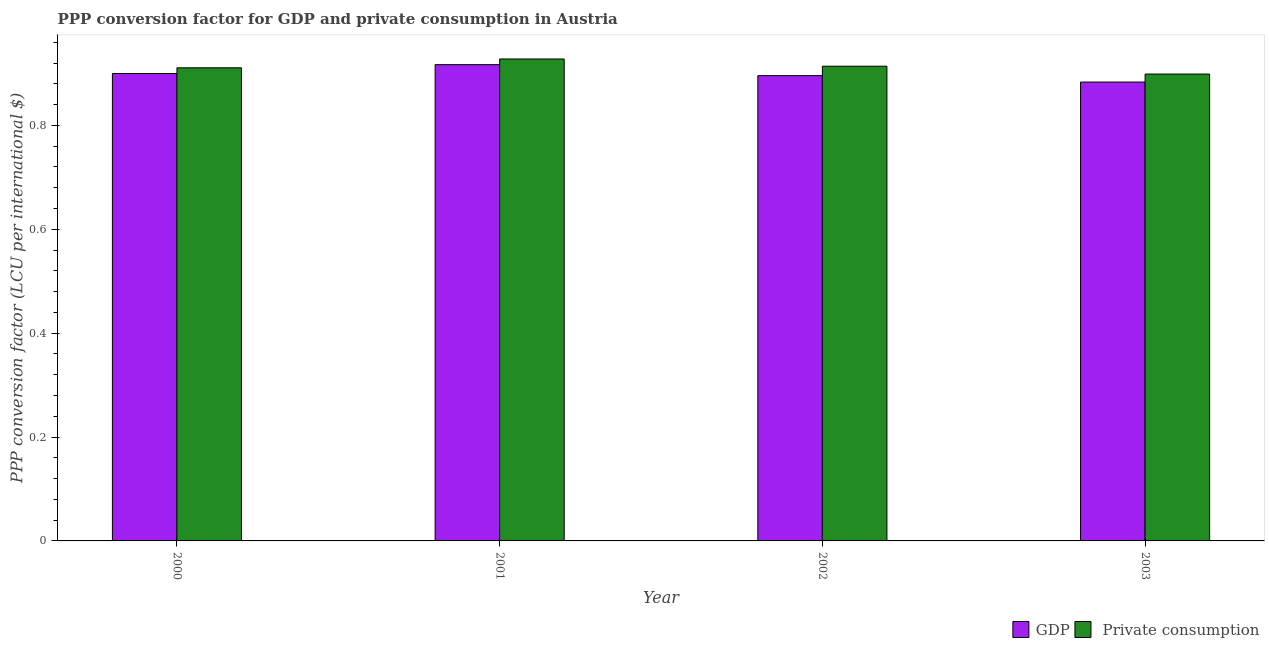Are the number of bars per tick equal to the number of legend labels?
Your answer should be very brief. Yes. How many bars are there on the 2nd tick from the left?
Your answer should be compact. 2. What is the label of the 1st group of bars from the left?
Your answer should be compact. 2000. What is the ppp conversion factor for gdp in 2003?
Keep it short and to the point. 0.88. Across all years, what is the maximum ppp conversion factor for private consumption?
Offer a very short reply. 0.93. Across all years, what is the minimum ppp conversion factor for gdp?
Your answer should be compact. 0.88. What is the total ppp conversion factor for gdp in the graph?
Your response must be concise. 3.6. What is the difference between the ppp conversion factor for gdp in 2001 and that in 2003?
Your answer should be very brief. 0.03. What is the difference between the ppp conversion factor for gdp in 2003 and the ppp conversion factor for private consumption in 2001?
Provide a succinct answer. -0.03. What is the average ppp conversion factor for private consumption per year?
Provide a succinct answer. 0.91. In the year 2001, what is the difference between the ppp conversion factor for private consumption and ppp conversion factor for gdp?
Offer a terse response. 0. What is the ratio of the ppp conversion factor for gdp in 2000 to that in 2001?
Your response must be concise. 0.98. Is the ppp conversion factor for gdp in 2001 less than that in 2003?
Offer a terse response. No. What is the difference between the highest and the second highest ppp conversion factor for private consumption?
Your response must be concise. 0.01. What is the difference between the highest and the lowest ppp conversion factor for gdp?
Make the answer very short. 0.03. In how many years, is the ppp conversion factor for gdp greater than the average ppp conversion factor for gdp taken over all years?
Keep it short and to the point. 2. What does the 2nd bar from the left in 2000 represents?
Give a very brief answer.  Private consumption. What does the 2nd bar from the right in 2002 represents?
Your answer should be compact. GDP. How many bars are there?
Make the answer very short. 8. How many years are there in the graph?
Keep it short and to the point. 4. Does the graph contain grids?
Keep it short and to the point. No. Where does the legend appear in the graph?
Offer a terse response. Bottom right. What is the title of the graph?
Provide a short and direct response. PPP conversion factor for GDP and private consumption in Austria. What is the label or title of the Y-axis?
Provide a succinct answer. PPP conversion factor (LCU per international $). What is the PPP conversion factor (LCU per international $) in GDP in 2000?
Keep it short and to the point. 0.9. What is the PPP conversion factor (LCU per international $) of  Private consumption in 2000?
Your response must be concise. 0.91. What is the PPP conversion factor (LCU per international $) in GDP in 2001?
Keep it short and to the point. 0.92. What is the PPP conversion factor (LCU per international $) in  Private consumption in 2001?
Offer a very short reply. 0.93. What is the PPP conversion factor (LCU per international $) of GDP in 2002?
Give a very brief answer. 0.9. What is the PPP conversion factor (LCU per international $) of  Private consumption in 2002?
Your answer should be very brief. 0.91. What is the PPP conversion factor (LCU per international $) in GDP in 2003?
Ensure brevity in your answer.  0.88. What is the PPP conversion factor (LCU per international $) in  Private consumption in 2003?
Your response must be concise. 0.9. Across all years, what is the maximum PPP conversion factor (LCU per international $) in GDP?
Ensure brevity in your answer.  0.92. Across all years, what is the maximum PPP conversion factor (LCU per international $) of  Private consumption?
Keep it short and to the point. 0.93. Across all years, what is the minimum PPP conversion factor (LCU per international $) in GDP?
Your answer should be very brief. 0.88. Across all years, what is the minimum PPP conversion factor (LCU per international $) of  Private consumption?
Give a very brief answer. 0.9. What is the total PPP conversion factor (LCU per international $) in GDP in the graph?
Make the answer very short. 3.6. What is the total PPP conversion factor (LCU per international $) of  Private consumption in the graph?
Keep it short and to the point. 3.65. What is the difference between the PPP conversion factor (LCU per international $) in GDP in 2000 and that in 2001?
Offer a very short reply. -0.02. What is the difference between the PPP conversion factor (LCU per international $) of  Private consumption in 2000 and that in 2001?
Give a very brief answer. -0.02. What is the difference between the PPP conversion factor (LCU per international $) in GDP in 2000 and that in 2002?
Your answer should be very brief. 0. What is the difference between the PPP conversion factor (LCU per international $) of  Private consumption in 2000 and that in 2002?
Your answer should be compact. -0. What is the difference between the PPP conversion factor (LCU per international $) in GDP in 2000 and that in 2003?
Your response must be concise. 0.02. What is the difference between the PPP conversion factor (LCU per international $) of  Private consumption in 2000 and that in 2003?
Your answer should be compact. 0.01. What is the difference between the PPP conversion factor (LCU per international $) of GDP in 2001 and that in 2002?
Provide a succinct answer. 0.02. What is the difference between the PPP conversion factor (LCU per international $) of  Private consumption in 2001 and that in 2002?
Provide a succinct answer. 0.01. What is the difference between the PPP conversion factor (LCU per international $) in GDP in 2001 and that in 2003?
Provide a succinct answer. 0.03. What is the difference between the PPP conversion factor (LCU per international $) of  Private consumption in 2001 and that in 2003?
Provide a succinct answer. 0.03. What is the difference between the PPP conversion factor (LCU per international $) of GDP in 2002 and that in 2003?
Give a very brief answer. 0.01. What is the difference between the PPP conversion factor (LCU per international $) in  Private consumption in 2002 and that in 2003?
Provide a short and direct response. 0.02. What is the difference between the PPP conversion factor (LCU per international $) of GDP in 2000 and the PPP conversion factor (LCU per international $) of  Private consumption in 2001?
Give a very brief answer. -0.03. What is the difference between the PPP conversion factor (LCU per international $) in GDP in 2000 and the PPP conversion factor (LCU per international $) in  Private consumption in 2002?
Ensure brevity in your answer.  -0.01. What is the difference between the PPP conversion factor (LCU per international $) of GDP in 2000 and the PPP conversion factor (LCU per international $) of  Private consumption in 2003?
Ensure brevity in your answer.  0. What is the difference between the PPP conversion factor (LCU per international $) in GDP in 2001 and the PPP conversion factor (LCU per international $) in  Private consumption in 2002?
Your response must be concise. 0. What is the difference between the PPP conversion factor (LCU per international $) in GDP in 2001 and the PPP conversion factor (LCU per international $) in  Private consumption in 2003?
Offer a terse response. 0.02. What is the difference between the PPP conversion factor (LCU per international $) of GDP in 2002 and the PPP conversion factor (LCU per international $) of  Private consumption in 2003?
Provide a short and direct response. -0. What is the average PPP conversion factor (LCU per international $) in GDP per year?
Make the answer very short. 0.9. What is the average PPP conversion factor (LCU per international $) in  Private consumption per year?
Your answer should be very brief. 0.91. In the year 2000, what is the difference between the PPP conversion factor (LCU per international $) in GDP and PPP conversion factor (LCU per international $) in  Private consumption?
Your answer should be compact. -0.01. In the year 2001, what is the difference between the PPP conversion factor (LCU per international $) in GDP and PPP conversion factor (LCU per international $) in  Private consumption?
Offer a very short reply. -0.01. In the year 2002, what is the difference between the PPP conversion factor (LCU per international $) in GDP and PPP conversion factor (LCU per international $) in  Private consumption?
Your answer should be compact. -0.02. In the year 2003, what is the difference between the PPP conversion factor (LCU per international $) of GDP and PPP conversion factor (LCU per international $) of  Private consumption?
Offer a terse response. -0.02. What is the ratio of the PPP conversion factor (LCU per international $) in GDP in 2000 to that in 2001?
Offer a very short reply. 0.98. What is the ratio of the PPP conversion factor (LCU per international $) of  Private consumption in 2000 to that in 2001?
Your answer should be compact. 0.98. What is the ratio of the PPP conversion factor (LCU per international $) of GDP in 2000 to that in 2002?
Make the answer very short. 1. What is the ratio of the PPP conversion factor (LCU per international $) of  Private consumption in 2000 to that in 2002?
Provide a succinct answer. 1. What is the ratio of the PPP conversion factor (LCU per international $) of GDP in 2000 to that in 2003?
Your answer should be compact. 1.02. What is the ratio of the PPP conversion factor (LCU per international $) of  Private consumption in 2000 to that in 2003?
Your answer should be compact. 1.01. What is the ratio of the PPP conversion factor (LCU per international $) of GDP in 2001 to that in 2002?
Offer a terse response. 1.02. What is the ratio of the PPP conversion factor (LCU per international $) of  Private consumption in 2001 to that in 2002?
Provide a succinct answer. 1.02. What is the ratio of the PPP conversion factor (LCU per international $) of GDP in 2001 to that in 2003?
Provide a short and direct response. 1.04. What is the ratio of the PPP conversion factor (LCU per international $) of  Private consumption in 2001 to that in 2003?
Your response must be concise. 1.03. What is the ratio of the PPP conversion factor (LCU per international $) in GDP in 2002 to that in 2003?
Provide a succinct answer. 1.01. What is the ratio of the PPP conversion factor (LCU per international $) in  Private consumption in 2002 to that in 2003?
Your answer should be compact. 1.02. What is the difference between the highest and the second highest PPP conversion factor (LCU per international $) in GDP?
Your answer should be compact. 0.02. What is the difference between the highest and the second highest PPP conversion factor (LCU per international $) of  Private consumption?
Keep it short and to the point. 0.01. What is the difference between the highest and the lowest PPP conversion factor (LCU per international $) of GDP?
Make the answer very short. 0.03. What is the difference between the highest and the lowest PPP conversion factor (LCU per international $) in  Private consumption?
Provide a short and direct response. 0.03. 